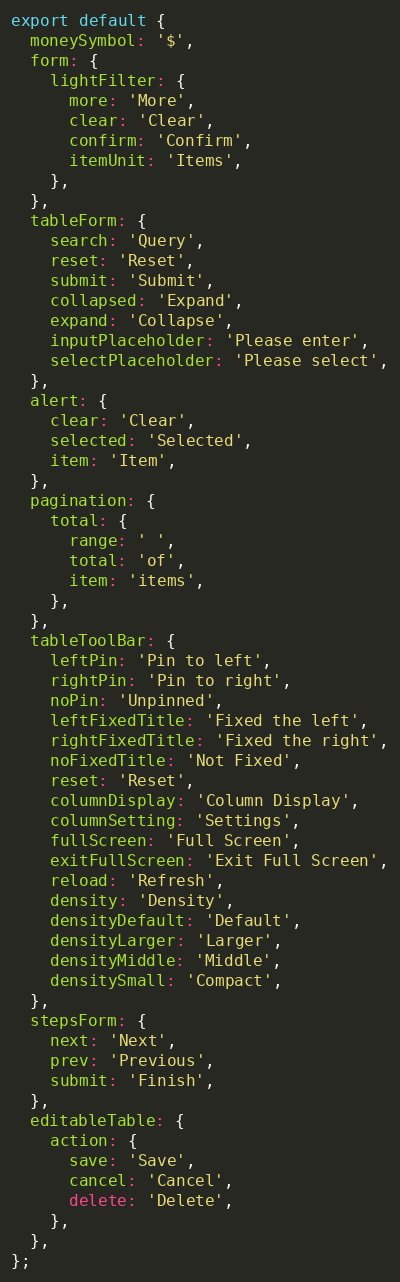Convert code to text. <code><loc_0><loc_0><loc_500><loc_500><_TypeScript_>export default {
  moneySymbol: '$',
  form: {
    lightFilter: {
      more: 'More',
      clear: 'Clear',
      confirm: 'Confirm',
      itemUnit: 'Items',
    },
  },
  tableForm: {
    search: 'Query',
    reset: 'Reset',
    submit: 'Submit',
    collapsed: 'Expand',
    expand: 'Collapse',
    inputPlaceholder: 'Please enter',
    selectPlaceholder: 'Please select',
  },
  alert: {
    clear: 'Clear',
    selected: 'Selected',
    item: 'Item',
  },
  pagination: {
    total: {
      range: ' ',
      total: 'of',
      item: 'items',
    },
  },
  tableToolBar: {
    leftPin: 'Pin to left',
    rightPin: 'Pin to right',
    noPin: 'Unpinned',
    leftFixedTitle: 'Fixed the left',
    rightFixedTitle: 'Fixed the right',
    noFixedTitle: 'Not Fixed',
    reset: 'Reset',
    columnDisplay: 'Column Display',
    columnSetting: 'Settings',
    fullScreen: 'Full Screen',
    exitFullScreen: 'Exit Full Screen',
    reload: 'Refresh',
    density: 'Density',
    densityDefault: 'Default',
    densityLarger: 'Larger',
    densityMiddle: 'Middle',
    densitySmall: 'Compact',
  },
  stepsForm: {
    next: 'Next',
    prev: 'Previous',
    submit: 'Finish',
  },
  editableTable: {
    action: {
      save: 'Save',
      cancel: 'Cancel',
      delete: 'Delete',
    },
  },
};
</code> 